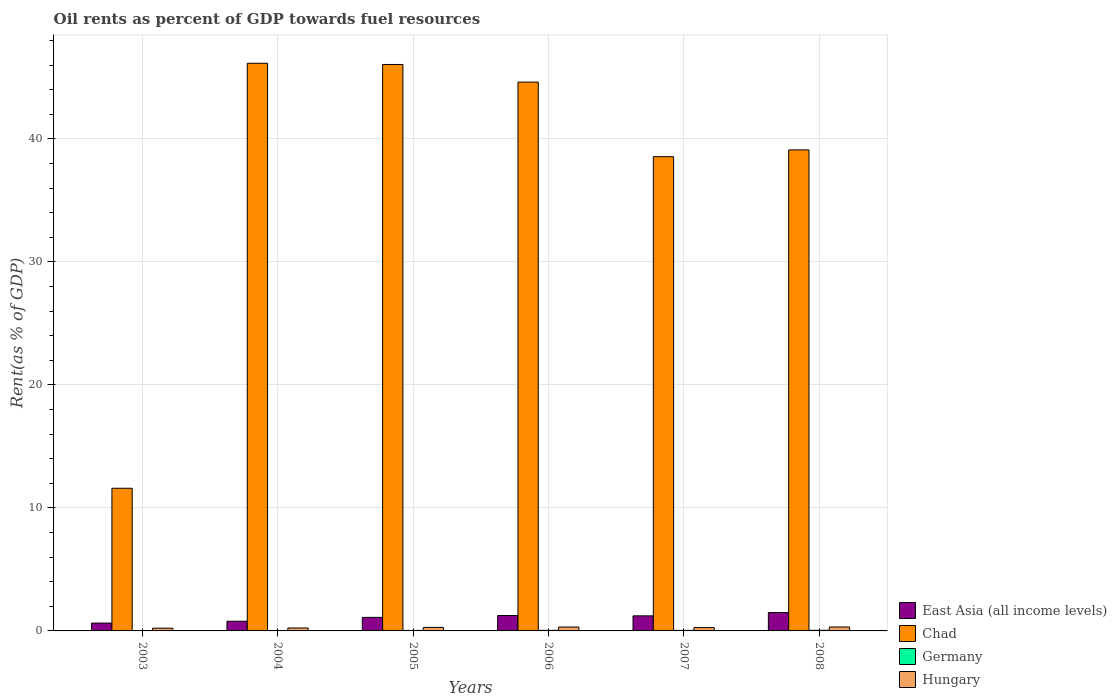How many groups of bars are there?
Offer a very short reply. 6. Are the number of bars per tick equal to the number of legend labels?
Ensure brevity in your answer.  Yes. Are the number of bars on each tick of the X-axis equal?
Ensure brevity in your answer.  Yes. How many bars are there on the 3rd tick from the left?
Keep it short and to the point. 4. In how many cases, is the number of bars for a given year not equal to the number of legend labels?
Offer a terse response. 0. What is the oil rent in Chad in 2004?
Ensure brevity in your answer.  46.15. Across all years, what is the maximum oil rent in Germany?
Give a very brief answer. 0.05. Across all years, what is the minimum oil rent in Germany?
Provide a short and direct response. 0.02. In which year was the oil rent in Hungary maximum?
Provide a short and direct response. 2008. In which year was the oil rent in Chad minimum?
Offer a terse response. 2003. What is the total oil rent in East Asia (all income levels) in the graph?
Your answer should be compact. 6.5. What is the difference between the oil rent in Germany in 2004 and that in 2006?
Ensure brevity in your answer.  -0.02. What is the difference between the oil rent in East Asia (all income levels) in 2007 and the oil rent in Germany in 2005?
Provide a succinct answer. 1.18. What is the average oil rent in Chad per year?
Your response must be concise. 37.68. In the year 2004, what is the difference between the oil rent in Hungary and oil rent in East Asia (all income levels)?
Keep it short and to the point. -0.55. In how many years, is the oil rent in Germany greater than 10 %?
Offer a terse response. 0. What is the ratio of the oil rent in Germany in 2003 to that in 2006?
Ensure brevity in your answer.  0.53. Is the oil rent in Hungary in 2005 less than that in 2006?
Ensure brevity in your answer.  Yes. Is the difference between the oil rent in Hungary in 2006 and 2008 greater than the difference between the oil rent in East Asia (all income levels) in 2006 and 2008?
Provide a succinct answer. Yes. What is the difference between the highest and the second highest oil rent in Hungary?
Make the answer very short. 0. What is the difference between the highest and the lowest oil rent in Hungary?
Your response must be concise. 0.1. Is the sum of the oil rent in Chad in 2003 and 2007 greater than the maximum oil rent in Germany across all years?
Your response must be concise. Yes. What does the 4th bar from the left in 2006 represents?
Ensure brevity in your answer.  Hungary. How many bars are there?
Offer a very short reply. 24. Are all the bars in the graph horizontal?
Keep it short and to the point. No. How many years are there in the graph?
Keep it short and to the point. 6. Are the values on the major ticks of Y-axis written in scientific E-notation?
Ensure brevity in your answer.  No. How are the legend labels stacked?
Keep it short and to the point. Vertical. What is the title of the graph?
Your response must be concise. Oil rents as percent of GDP towards fuel resources. Does "Libya" appear as one of the legend labels in the graph?
Your answer should be compact. No. What is the label or title of the X-axis?
Offer a terse response. Years. What is the label or title of the Y-axis?
Your response must be concise. Rent(as % of GDP). What is the Rent(as % of GDP) in East Asia (all income levels) in 2003?
Keep it short and to the point. 0.64. What is the Rent(as % of GDP) of Chad in 2003?
Your response must be concise. 11.6. What is the Rent(as % of GDP) of Germany in 2003?
Ensure brevity in your answer.  0.02. What is the Rent(as % of GDP) in Hungary in 2003?
Your response must be concise. 0.22. What is the Rent(as % of GDP) in East Asia (all income levels) in 2004?
Ensure brevity in your answer.  0.79. What is the Rent(as % of GDP) in Chad in 2004?
Your answer should be very brief. 46.15. What is the Rent(as % of GDP) in Germany in 2004?
Offer a terse response. 0.03. What is the Rent(as % of GDP) in Hungary in 2004?
Make the answer very short. 0.24. What is the Rent(as % of GDP) in East Asia (all income levels) in 2005?
Offer a terse response. 1.1. What is the Rent(as % of GDP) of Chad in 2005?
Keep it short and to the point. 46.05. What is the Rent(as % of GDP) in Germany in 2005?
Your answer should be compact. 0.04. What is the Rent(as % of GDP) in Hungary in 2005?
Provide a succinct answer. 0.28. What is the Rent(as % of GDP) of East Asia (all income levels) in 2006?
Provide a short and direct response. 1.25. What is the Rent(as % of GDP) in Chad in 2006?
Offer a very short reply. 44.62. What is the Rent(as % of GDP) in Germany in 2006?
Ensure brevity in your answer.  0.05. What is the Rent(as % of GDP) of Hungary in 2006?
Provide a succinct answer. 0.32. What is the Rent(as % of GDP) in East Asia (all income levels) in 2007?
Ensure brevity in your answer.  1.22. What is the Rent(as % of GDP) of Chad in 2007?
Provide a short and direct response. 38.55. What is the Rent(as % of GDP) of Germany in 2007?
Provide a succinct answer. 0.04. What is the Rent(as % of GDP) in Hungary in 2007?
Your answer should be compact. 0.27. What is the Rent(as % of GDP) of East Asia (all income levels) in 2008?
Ensure brevity in your answer.  1.5. What is the Rent(as % of GDP) of Chad in 2008?
Offer a very short reply. 39.11. What is the Rent(as % of GDP) in Germany in 2008?
Give a very brief answer. 0.05. What is the Rent(as % of GDP) of Hungary in 2008?
Offer a terse response. 0.32. Across all years, what is the maximum Rent(as % of GDP) in East Asia (all income levels)?
Your response must be concise. 1.5. Across all years, what is the maximum Rent(as % of GDP) in Chad?
Offer a terse response. 46.15. Across all years, what is the maximum Rent(as % of GDP) of Germany?
Give a very brief answer. 0.05. Across all years, what is the maximum Rent(as % of GDP) of Hungary?
Offer a terse response. 0.32. Across all years, what is the minimum Rent(as % of GDP) in East Asia (all income levels)?
Give a very brief answer. 0.64. Across all years, what is the minimum Rent(as % of GDP) of Chad?
Your answer should be very brief. 11.6. Across all years, what is the minimum Rent(as % of GDP) in Germany?
Offer a very short reply. 0.02. Across all years, what is the minimum Rent(as % of GDP) in Hungary?
Your answer should be very brief. 0.22. What is the total Rent(as % of GDP) in East Asia (all income levels) in the graph?
Offer a terse response. 6.5. What is the total Rent(as % of GDP) of Chad in the graph?
Your answer should be compact. 226.07. What is the total Rent(as % of GDP) in Germany in the graph?
Offer a very short reply. 0.23. What is the total Rent(as % of GDP) in Hungary in the graph?
Your answer should be very brief. 1.65. What is the difference between the Rent(as % of GDP) in East Asia (all income levels) in 2003 and that in 2004?
Provide a short and direct response. -0.15. What is the difference between the Rent(as % of GDP) in Chad in 2003 and that in 2004?
Your answer should be compact. -34.55. What is the difference between the Rent(as % of GDP) of Germany in 2003 and that in 2004?
Provide a succinct answer. -0. What is the difference between the Rent(as % of GDP) in Hungary in 2003 and that in 2004?
Your answer should be compact. -0.02. What is the difference between the Rent(as % of GDP) in East Asia (all income levels) in 2003 and that in 2005?
Offer a very short reply. -0.46. What is the difference between the Rent(as % of GDP) of Chad in 2003 and that in 2005?
Your response must be concise. -34.45. What is the difference between the Rent(as % of GDP) in Germany in 2003 and that in 2005?
Provide a short and direct response. -0.02. What is the difference between the Rent(as % of GDP) of Hungary in 2003 and that in 2005?
Ensure brevity in your answer.  -0.06. What is the difference between the Rent(as % of GDP) in East Asia (all income levels) in 2003 and that in 2006?
Keep it short and to the point. -0.61. What is the difference between the Rent(as % of GDP) in Chad in 2003 and that in 2006?
Your response must be concise. -33.02. What is the difference between the Rent(as % of GDP) of Germany in 2003 and that in 2006?
Ensure brevity in your answer.  -0.02. What is the difference between the Rent(as % of GDP) of Hungary in 2003 and that in 2006?
Make the answer very short. -0.09. What is the difference between the Rent(as % of GDP) in East Asia (all income levels) in 2003 and that in 2007?
Your response must be concise. -0.59. What is the difference between the Rent(as % of GDP) in Chad in 2003 and that in 2007?
Make the answer very short. -26.96. What is the difference between the Rent(as % of GDP) of Germany in 2003 and that in 2007?
Keep it short and to the point. -0.02. What is the difference between the Rent(as % of GDP) in Hungary in 2003 and that in 2007?
Your answer should be very brief. -0.05. What is the difference between the Rent(as % of GDP) of East Asia (all income levels) in 2003 and that in 2008?
Give a very brief answer. -0.86. What is the difference between the Rent(as % of GDP) in Chad in 2003 and that in 2008?
Your answer should be very brief. -27.51. What is the difference between the Rent(as % of GDP) of Germany in 2003 and that in 2008?
Your response must be concise. -0.03. What is the difference between the Rent(as % of GDP) of Hungary in 2003 and that in 2008?
Make the answer very short. -0.1. What is the difference between the Rent(as % of GDP) of East Asia (all income levels) in 2004 and that in 2005?
Your answer should be compact. -0.31. What is the difference between the Rent(as % of GDP) in Chad in 2004 and that in 2005?
Offer a terse response. 0.1. What is the difference between the Rent(as % of GDP) of Germany in 2004 and that in 2005?
Keep it short and to the point. -0.01. What is the difference between the Rent(as % of GDP) of Hungary in 2004 and that in 2005?
Provide a short and direct response. -0.05. What is the difference between the Rent(as % of GDP) in East Asia (all income levels) in 2004 and that in 2006?
Keep it short and to the point. -0.46. What is the difference between the Rent(as % of GDP) of Chad in 2004 and that in 2006?
Ensure brevity in your answer.  1.53. What is the difference between the Rent(as % of GDP) in Germany in 2004 and that in 2006?
Give a very brief answer. -0.02. What is the difference between the Rent(as % of GDP) of Hungary in 2004 and that in 2006?
Ensure brevity in your answer.  -0.08. What is the difference between the Rent(as % of GDP) of East Asia (all income levels) in 2004 and that in 2007?
Offer a terse response. -0.44. What is the difference between the Rent(as % of GDP) in Chad in 2004 and that in 2007?
Give a very brief answer. 7.6. What is the difference between the Rent(as % of GDP) of Germany in 2004 and that in 2007?
Your answer should be compact. -0.02. What is the difference between the Rent(as % of GDP) in Hungary in 2004 and that in 2007?
Provide a short and direct response. -0.03. What is the difference between the Rent(as % of GDP) in East Asia (all income levels) in 2004 and that in 2008?
Offer a terse response. -0.71. What is the difference between the Rent(as % of GDP) in Chad in 2004 and that in 2008?
Offer a terse response. 7.04. What is the difference between the Rent(as % of GDP) in Germany in 2004 and that in 2008?
Keep it short and to the point. -0.02. What is the difference between the Rent(as % of GDP) of Hungary in 2004 and that in 2008?
Offer a very short reply. -0.08. What is the difference between the Rent(as % of GDP) in East Asia (all income levels) in 2005 and that in 2006?
Offer a terse response. -0.15. What is the difference between the Rent(as % of GDP) in Chad in 2005 and that in 2006?
Your answer should be very brief. 1.43. What is the difference between the Rent(as % of GDP) of Germany in 2005 and that in 2006?
Give a very brief answer. -0.01. What is the difference between the Rent(as % of GDP) of Hungary in 2005 and that in 2006?
Offer a very short reply. -0.03. What is the difference between the Rent(as % of GDP) in East Asia (all income levels) in 2005 and that in 2007?
Provide a succinct answer. -0.12. What is the difference between the Rent(as % of GDP) in Chad in 2005 and that in 2007?
Make the answer very short. 7.5. What is the difference between the Rent(as % of GDP) in Germany in 2005 and that in 2007?
Your answer should be compact. -0. What is the difference between the Rent(as % of GDP) in Hungary in 2005 and that in 2007?
Your answer should be compact. 0.01. What is the difference between the Rent(as % of GDP) of East Asia (all income levels) in 2005 and that in 2008?
Give a very brief answer. -0.39. What is the difference between the Rent(as % of GDP) of Chad in 2005 and that in 2008?
Provide a succinct answer. 6.94. What is the difference between the Rent(as % of GDP) of Germany in 2005 and that in 2008?
Your answer should be very brief. -0.01. What is the difference between the Rent(as % of GDP) in Hungary in 2005 and that in 2008?
Offer a very short reply. -0.04. What is the difference between the Rent(as % of GDP) of East Asia (all income levels) in 2006 and that in 2007?
Your answer should be compact. 0.03. What is the difference between the Rent(as % of GDP) in Chad in 2006 and that in 2007?
Your answer should be very brief. 6.06. What is the difference between the Rent(as % of GDP) in Germany in 2006 and that in 2007?
Offer a terse response. 0. What is the difference between the Rent(as % of GDP) in Hungary in 2006 and that in 2007?
Your answer should be compact. 0.04. What is the difference between the Rent(as % of GDP) in East Asia (all income levels) in 2006 and that in 2008?
Provide a succinct answer. -0.24. What is the difference between the Rent(as % of GDP) in Chad in 2006 and that in 2008?
Ensure brevity in your answer.  5.51. What is the difference between the Rent(as % of GDP) of Germany in 2006 and that in 2008?
Your response must be concise. -0. What is the difference between the Rent(as % of GDP) in Hungary in 2006 and that in 2008?
Keep it short and to the point. -0. What is the difference between the Rent(as % of GDP) in East Asia (all income levels) in 2007 and that in 2008?
Offer a very short reply. -0.27. What is the difference between the Rent(as % of GDP) in Chad in 2007 and that in 2008?
Ensure brevity in your answer.  -0.55. What is the difference between the Rent(as % of GDP) of Germany in 2007 and that in 2008?
Your answer should be compact. -0.01. What is the difference between the Rent(as % of GDP) in Hungary in 2007 and that in 2008?
Provide a succinct answer. -0.05. What is the difference between the Rent(as % of GDP) of East Asia (all income levels) in 2003 and the Rent(as % of GDP) of Chad in 2004?
Your answer should be very brief. -45.51. What is the difference between the Rent(as % of GDP) of East Asia (all income levels) in 2003 and the Rent(as % of GDP) of Germany in 2004?
Give a very brief answer. 0.61. What is the difference between the Rent(as % of GDP) in East Asia (all income levels) in 2003 and the Rent(as % of GDP) in Hungary in 2004?
Provide a short and direct response. 0.4. What is the difference between the Rent(as % of GDP) in Chad in 2003 and the Rent(as % of GDP) in Germany in 2004?
Keep it short and to the point. 11.57. What is the difference between the Rent(as % of GDP) of Chad in 2003 and the Rent(as % of GDP) of Hungary in 2004?
Your response must be concise. 11.36. What is the difference between the Rent(as % of GDP) in Germany in 2003 and the Rent(as % of GDP) in Hungary in 2004?
Offer a very short reply. -0.21. What is the difference between the Rent(as % of GDP) of East Asia (all income levels) in 2003 and the Rent(as % of GDP) of Chad in 2005?
Your response must be concise. -45.41. What is the difference between the Rent(as % of GDP) in East Asia (all income levels) in 2003 and the Rent(as % of GDP) in Germany in 2005?
Make the answer very short. 0.6. What is the difference between the Rent(as % of GDP) in East Asia (all income levels) in 2003 and the Rent(as % of GDP) in Hungary in 2005?
Give a very brief answer. 0.35. What is the difference between the Rent(as % of GDP) in Chad in 2003 and the Rent(as % of GDP) in Germany in 2005?
Offer a terse response. 11.56. What is the difference between the Rent(as % of GDP) in Chad in 2003 and the Rent(as % of GDP) in Hungary in 2005?
Offer a terse response. 11.31. What is the difference between the Rent(as % of GDP) in Germany in 2003 and the Rent(as % of GDP) in Hungary in 2005?
Offer a terse response. -0.26. What is the difference between the Rent(as % of GDP) of East Asia (all income levels) in 2003 and the Rent(as % of GDP) of Chad in 2006?
Keep it short and to the point. -43.98. What is the difference between the Rent(as % of GDP) of East Asia (all income levels) in 2003 and the Rent(as % of GDP) of Germany in 2006?
Provide a short and direct response. 0.59. What is the difference between the Rent(as % of GDP) in East Asia (all income levels) in 2003 and the Rent(as % of GDP) in Hungary in 2006?
Ensure brevity in your answer.  0.32. What is the difference between the Rent(as % of GDP) in Chad in 2003 and the Rent(as % of GDP) in Germany in 2006?
Ensure brevity in your answer.  11.55. What is the difference between the Rent(as % of GDP) in Chad in 2003 and the Rent(as % of GDP) in Hungary in 2006?
Provide a short and direct response. 11.28. What is the difference between the Rent(as % of GDP) of Germany in 2003 and the Rent(as % of GDP) of Hungary in 2006?
Keep it short and to the point. -0.29. What is the difference between the Rent(as % of GDP) of East Asia (all income levels) in 2003 and the Rent(as % of GDP) of Chad in 2007?
Provide a succinct answer. -37.92. What is the difference between the Rent(as % of GDP) of East Asia (all income levels) in 2003 and the Rent(as % of GDP) of Germany in 2007?
Provide a short and direct response. 0.59. What is the difference between the Rent(as % of GDP) of East Asia (all income levels) in 2003 and the Rent(as % of GDP) of Hungary in 2007?
Keep it short and to the point. 0.37. What is the difference between the Rent(as % of GDP) in Chad in 2003 and the Rent(as % of GDP) in Germany in 2007?
Offer a terse response. 11.55. What is the difference between the Rent(as % of GDP) of Chad in 2003 and the Rent(as % of GDP) of Hungary in 2007?
Ensure brevity in your answer.  11.33. What is the difference between the Rent(as % of GDP) of Germany in 2003 and the Rent(as % of GDP) of Hungary in 2007?
Make the answer very short. -0.25. What is the difference between the Rent(as % of GDP) in East Asia (all income levels) in 2003 and the Rent(as % of GDP) in Chad in 2008?
Ensure brevity in your answer.  -38.47. What is the difference between the Rent(as % of GDP) of East Asia (all income levels) in 2003 and the Rent(as % of GDP) of Germany in 2008?
Keep it short and to the point. 0.59. What is the difference between the Rent(as % of GDP) of East Asia (all income levels) in 2003 and the Rent(as % of GDP) of Hungary in 2008?
Offer a terse response. 0.32. What is the difference between the Rent(as % of GDP) of Chad in 2003 and the Rent(as % of GDP) of Germany in 2008?
Give a very brief answer. 11.55. What is the difference between the Rent(as % of GDP) in Chad in 2003 and the Rent(as % of GDP) in Hungary in 2008?
Provide a short and direct response. 11.28. What is the difference between the Rent(as % of GDP) of Germany in 2003 and the Rent(as % of GDP) of Hungary in 2008?
Give a very brief answer. -0.3. What is the difference between the Rent(as % of GDP) of East Asia (all income levels) in 2004 and the Rent(as % of GDP) of Chad in 2005?
Ensure brevity in your answer.  -45.26. What is the difference between the Rent(as % of GDP) in East Asia (all income levels) in 2004 and the Rent(as % of GDP) in Germany in 2005?
Provide a succinct answer. 0.75. What is the difference between the Rent(as % of GDP) in East Asia (all income levels) in 2004 and the Rent(as % of GDP) in Hungary in 2005?
Provide a short and direct response. 0.5. What is the difference between the Rent(as % of GDP) of Chad in 2004 and the Rent(as % of GDP) of Germany in 2005?
Ensure brevity in your answer.  46.11. What is the difference between the Rent(as % of GDP) of Chad in 2004 and the Rent(as % of GDP) of Hungary in 2005?
Your answer should be very brief. 45.86. What is the difference between the Rent(as % of GDP) in Germany in 2004 and the Rent(as % of GDP) in Hungary in 2005?
Offer a very short reply. -0.26. What is the difference between the Rent(as % of GDP) in East Asia (all income levels) in 2004 and the Rent(as % of GDP) in Chad in 2006?
Offer a very short reply. -43.83. What is the difference between the Rent(as % of GDP) of East Asia (all income levels) in 2004 and the Rent(as % of GDP) of Germany in 2006?
Your answer should be compact. 0.74. What is the difference between the Rent(as % of GDP) in East Asia (all income levels) in 2004 and the Rent(as % of GDP) in Hungary in 2006?
Your answer should be compact. 0.47. What is the difference between the Rent(as % of GDP) in Chad in 2004 and the Rent(as % of GDP) in Germany in 2006?
Give a very brief answer. 46.1. What is the difference between the Rent(as % of GDP) of Chad in 2004 and the Rent(as % of GDP) of Hungary in 2006?
Your response must be concise. 45.83. What is the difference between the Rent(as % of GDP) in Germany in 2004 and the Rent(as % of GDP) in Hungary in 2006?
Give a very brief answer. -0.29. What is the difference between the Rent(as % of GDP) in East Asia (all income levels) in 2004 and the Rent(as % of GDP) in Chad in 2007?
Your response must be concise. -37.77. What is the difference between the Rent(as % of GDP) of East Asia (all income levels) in 2004 and the Rent(as % of GDP) of Germany in 2007?
Give a very brief answer. 0.74. What is the difference between the Rent(as % of GDP) of East Asia (all income levels) in 2004 and the Rent(as % of GDP) of Hungary in 2007?
Your answer should be very brief. 0.52. What is the difference between the Rent(as % of GDP) of Chad in 2004 and the Rent(as % of GDP) of Germany in 2007?
Your answer should be compact. 46.11. What is the difference between the Rent(as % of GDP) in Chad in 2004 and the Rent(as % of GDP) in Hungary in 2007?
Your response must be concise. 45.88. What is the difference between the Rent(as % of GDP) of Germany in 2004 and the Rent(as % of GDP) of Hungary in 2007?
Keep it short and to the point. -0.24. What is the difference between the Rent(as % of GDP) of East Asia (all income levels) in 2004 and the Rent(as % of GDP) of Chad in 2008?
Provide a succinct answer. -38.32. What is the difference between the Rent(as % of GDP) in East Asia (all income levels) in 2004 and the Rent(as % of GDP) in Germany in 2008?
Offer a terse response. 0.74. What is the difference between the Rent(as % of GDP) in East Asia (all income levels) in 2004 and the Rent(as % of GDP) in Hungary in 2008?
Give a very brief answer. 0.47. What is the difference between the Rent(as % of GDP) of Chad in 2004 and the Rent(as % of GDP) of Germany in 2008?
Offer a very short reply. 46.1. What is the difference between the Rent(as % of GDP) of Chad in 2004 and the Rent(as % of GDP) of Hungary in 2008?
Offer a terse response. 45.83. What is the difference between the Rent(as % of GDP) in Germany in 2004 and the Rent(as % of GDP) in Hungary in 2008?
Your response must be concise. -0.29. What is the difference between the Rent(as % of GDP) of East Asia (all income levels) in 2005 and the Rent(as % of GDP) of Chad in 2006?
Offer a terse response. -43.51. What is the difference between the Rent(as % of GDP) of East Asia (all income levels) in 2005 and the Rent(as % of GDP) of Germany in 2006?
Provide a short and direct response. 1.06. What is the difference between the Rent(as % of GDP) in East Asia (all income levels) in 2005 and the Rent(as % of GDP) in Hungary in 2006?
Give a very brief answer. 0.79. What is the difference between the Rent(as % of GDP) of Chad in 2005 and the Rent(as % of GDP) of Germany in 2006?
Ensure brevity in your answer.  46. What is the difference between the Rent(as % of GDP) in Chad in 2005 and the Rent(as % of GDP) in Hungary in 2006?
Provide a short and direct response. 45.73. What is the difference between the Rent(as % of GDP) in Germany in 2005 and the Rent(as % of GDP) in Hungary in 2006?
Offer a terse response. -0.28. What is the difference between the Rent(as % of GDP) of East Asia (all income levels) in 2005 and the Rent(as % of GDP) of Chad in 2007?
Your answer should be compact. -37.45. What is the difference between the Rent(as % of GDP) in East Asia (all income levels) in 2005 and the Rent(as % of GDP) in Germany in 2007?
Provide a short and direct response. 1.06. What is the difference between the Rent(as % of GDP) of East Asia (all income levels) in 2005 and the Rent(as % of GDP) of Hungary in 2007?
Your response must be concise. 0.83. What is the difference between the Rent(as % of GDP) in Chad in 2005 and the Rent(as % of GDP) in Germany in 2007?
Give a very brief answer. 46.01. What is the difference between the Rent(as % of GDP) of Chad in 2005 and the Rent(as % of GDP) of Hungary in 2007?
Ensure brevity in your answer.  45.78. What is the difference between the Rent(as % of GDP) in Germany in 2005 and the Rent(as % of GDP) in Hungary in 2007?
Your answer should be compact. -0.23. What is the difference between the Rent(as % of GDP) of East Asia (all income levels) in 2005 and the Rent(as % of GDP) of Chad in 2008?
Your answer should be compact. -38. What is the difference between the Rent(as % of GDP) of East Asia (all income levels) in 2005 and the Rent(as % of GDP) of Germany in 2008?
Make the answer very short. 1.05. What is the difference between the Rent(as % of GDP) of East Asia (all income levels) in 2005 and the Rent(as % of GDP) of Hungary in 2008?
Keep it short and to the point. 0.78. What is the difference between the Rent(as % of GDP) of Chad in 2005 and the Rent(as % of GDP) of Germany in 2008?
Your response must be concise. 46. What is the difference between the Rent(as % of GDP) in Chad in 2005 and the Rent(as % of GDP) in Hungary in 2008?
Your answer should be very brief. 45.73. What is the difference between the Rent(as % of GDP) of Germany in 2005 and the Rent(as % of GDP) of Hungary in 2008?
Keep it short and to the point. -0.28. What is the difference between the Rent(as % of GDP) of East Asia (all income levels) in 2006 and the Rent(as % of GDP) of Chad in 2007?
Your response must be concise. -37.3. What is the difference between the Rent(as % of GDP) of East Asia (all income levels) in 2006 and the Rent(as % of GDP) of Germany in 2007?
Give a very brief answer. 1.21. What is the difference between the Rent(as % of GDP) of East Asia (all income levels) in 2006 and the Rent(as % of GDP) of Hungary in 2007?
Your answer should be very brief. 0.98. What is the difference between the Rent(as % of GDP) in Chad in 2006 and the Rent(as % of GDP) in Germany in 2007?
Keep it short and to the point. 44.57. What is the difference between the Rent(as % of GDP) in Chad in 2006 and the Rent(as % of GDP) in Hungary in 2007?
Your response must be concise. 44.35. What is the difference between the Rent(as % of GDP) of Germany in 2006 and the Rent(as % of GDP) of Hungary in 2007?
Provide a succinct answer. -0.23. What is the difference between the Rent(as % of GDP) in East Asia (all income levels) in 2006 and the Rent(as % of GDP) in Chad in 2008?
Your response must be concise. -37.85. What is the difference between the Rent(as % of GDP) in East Asia (all income levels) in 2006 and the Rent(as % of GDP) in Germany in 2008?
Offer a very short reply. 1.2. What is the difference between the Rent(as % of GDP) in East Asia (all income levels) in 2006 and the Rent(as % of GDP) in Hungary in 2008?
Keep it short and to the point. 0.93. What is the difference between the Rent(as % of GDP) of Chad in 2006 and the Rent(as % of GDP) of Germany in 2008?
Keep it short and to the point. 44.57. What is the difference between the Rent(as % of GDP) in Chad in 2006 and the Rent(as % of GDP) in Hungary in 2008?
Make the answer very short. 44.3. What is the difference between the Rent(as % of GDP) of Germany in 2006 and the Rent(as % of GDP) of Hungary in 2008?
Offer a very short reply. -0.27. What is the difference between the Rent(as % of GDP) of East Asia (all income levels) in 2007 and the Rent(as % of GDP) of Chad in 2008?
Offer a terse response. -37.88. What is the difference between the Rent(as % of GDP) in East Asia (all income levels) in 2007 and the Rent(as % of GDP) in Germany in 2008?
Ensure brevity in your answer.  1.18. What is the difference between the Rent(as % of GDP) of East Asia (all income levels) in 2007 and the Rent(as % of GDP) of Hungary in 2008?
Keep it short and to the point. 0.9. What is the difference between the Rent(as % of GDP) of Chad in 2007 and the Rent(as % of GDP) of Germany in 2008?
Your answer should be compact. 38.5. What is the difference between the Rent(as % of GDP) in Chad in 2007 and the Rent(as % of GDP) in Hungary in 2008?
Your answer should be very brief. 38.23. What is the difference between the Rent(as % of GDP) in Germany in 2007 and the Rent(as % of GDP) in Hungary in 2008?
Make the answer very short. -0.28. What is the average Rent(as % of GDP) of East Asia (all income levels) per year?
Ensure brevity in your answer.  1.08. What is the average Rent(as % of GDP) of Chad per year?
Offer a terse response. 37.68. What is the average Rent(as % of GDP) in Germany per year?
Offer a very short reply. 0.04. What is the average Rent(as % of GDP) in Hungary per year?
Your answer should be compact. 0.28. In the year 2003, what is the difference between the Rent(as % of GDP) in East Asia (all income levels) and Rent(as % of GDP) in Chad?
Give a very brief answer. -10.96. In the year 2003, what is the difference between the Rent(as % of GDP) in East Asia (all income levels) and Rent(as % of GDP) in Germany?
Offer a very short reply. 0.61. In the year 2003, what is the difference between the Rent(as % of GDP) of East Asia (all income levels) and Rent(as % of GDP) of Hungary?
Your answer should be very brief. 0.42. In the year 2003, what is the difference between the Rent(as % of GDP) in Chad and Rent(as % of GDP) in Germany?
Make the answer very short. 11.57. In the year 2003, what is the difference between the Rent(as % of GDP) of Chad and Rent(as % of GDP) of Hungary?
Your answer should be compact. 11.38. In the year 2003, what is the difference between the Rent(as % of GDP) in Germany and Rent(as % of GDP) in Hungary?
Give a very brief answer. -0.2. In the year 2004, what is the difference between the Rent(as % of GDP) of East Asia (all income levels) and Rent(as % of GDP) of Chad?
Give a very brief answer. -45.36. In the year 2004, what is the difference between the Rent(as % of GDP) in East Asia (all income levels) and Rent(as % of GDP) in Germany?
Offer a very short reply. 0.76. In the year 2004, what is the difference between the Rent(as % of GDP) of East Asia (all income levels) and Rent(as % of GDP) of Hungary?
Give a very brief answer. 0.55. In the year 2004, what is the difference between the Rent(as % of GDP) in Chad and Rent(as % of GDP) in Germany?
Give a very brief answer. 46.12. In the year 2004, what is the difference between the Rent(as % of GDP) in Chad and Rent(as % of GDP) in Hungary?
Your response must be concise. 45.91. In the year 2004, what is the difference between the Rent(as % of GDP) in Germany and Rent(as % of GDP) in Hungary?
Ensure brevity in your answer.  -0.21. In the year 2005, what is the difference between the Rent(as % of GDP) in East Asia (all income levels) and Rent(as % of GDP) in Chad?
Offer a very short reply. -44.95. In the year 2005, what is the difference between the Rent(as % of GDP) of East Asia (all income levels) and Rent(as % of GDP) of Germany?
Make the answer very short. 1.06. In the year 2005, what is the difference between the Rent(as % of GDP) in East Asia (all income levels) and Rent(as % of GDP) in Hungary?
Offer a very short reply. 0.82. In the year 2005, what is the difference between the Rent(as % of GDP) in Chad and Rent(as % of GDP) in Germany?
Offer a very short reply. 46.01. In the year 2005, what is the difference between the Rent(as % of GDP) in Chad and Rent(as % of GDP) in Hungary?
Provide a short and direct response. 45.77. In the year 2005, what is the difference between the Rent(as % of GDP) in Germany and Rent(as % of GDP) in Hungary?
Your answer should be very brief. -0.24. In the year 2006, what is the difference between the Rent(as % of GDP) in East Asia (all income levels) and Rent(as % of GDP) in Chad?
Your response must be concise. -43.37. In the year 2006, what is the difference between the Rent(as % of GDP) in East Asia (all income levels) and Rent(as % of GDP) in Germany?
Ensure brevity in your answer.  1.21. In the year 2006, what is the difference between the Rent(as % of GDP) in East Asia (all income levels) and Rent(as % of GDP) in Hungary?
Keep it short and to the point. 0.94. In the year 2006, what is the difference between the Rent(as % of GDP) of Chad and Rent(as % of GDP) of Germany?
Offer a terse response. 44.57. In the year 2006, what is the difference between the Rent(as % of GDP) in Chad and Rent(as % of GDP) in Hungary?
Offer a terse response. 44.3. In the year 2006, what is the difference between the Rent(as % of GDP) of Germany and Rent(as % of GDP) of Hungary?
Provide a short and direct response. -0.27. In the year 2007, what is the difference between the Rent(as % of GDP) of East Asia (all income levels) and Rent(as % of GDP) of Chad?
Make the answer very short. -37.33. In the year 2007, what is the difference between the Rent(as % of GDP) of East Asia (all income levels) and Rent(as % of GDP) of Germany?
Offer a very short reply. 1.18. In the year 2007, what is the difference between the Rent(as % of GDP) of East Asia (all income levels) and Rent(as % of GDP) of Hungary?
Provide a succinct answer. 0.95. In the year 2007, what is the difference between the Rent(as % of GDP) in Chad and Rent(as % of GDP) in Germany?
Give a very brief answer. 38.51. In the year 2007, what is the difference between the Rent(as % of GDP) of Chad and Rent(as % of GDP) of Hungary?
Your response must be concise. 38.28. In the year 2007, what is the difference between the Rent(as % of GDP) in Germany and Rent(as % of GDP) in Hungary?
Make the answer very short. -0.23. In the year 2008, what is the difference between the Rent(as % of GDP) of East Asia (all income levels) and Rent(as % of GDP) of Chad?
Make the answer very short. -37.61. In the year 2008, what is the difference between the Rent(as % of GDP) of East Asia (all income levels) and Rent(as % of GDP) of Germany?
Keep it short and to the point. 1.45. In the year 2008, what is the difference between the Rent(as % of GDP) of East Asia (all income levels) and Rent(as % of GDP) of Hungary?
Give a very brief answer. 1.18. In the year 2008, what is the difference between the Rent(as % of GDP) in Chad and Rent(as % of GDP) in Germany?
Offer a very short reply. 39.06. In the year 2008, what is the difference between the Rent(as % of GDP) in Chad and Rent(as % of GDP) in Hungary?
Offer a terse response. 38.79. In the year 2008, what is the difference between the Rent(as % of GDP) in Germany and Rent(as % of GDP) in Hungary?
Provide a succinct answer. -0.27. What is the ratio of the Rent(as % of GDP) in East Asia (all income levels) in 2003 to that in 2004?
Provide a short and direct response. 0.81. What is the ratio of the Rent(as % of GDP) in Chad in 2003 to that in 2004?
Offer a terse response. 0.25. What is the ratio of the Rent(as % of GDP) of Germany in 2003 to that in 2004?
Offer a very short reply. 0.87. What is the ratio of the Rent(as % of GDP) in Hungary in 2003 to that in 2004?
Offer a very short reply. 0.93. What is the ratio of the Rent(as % of GDP) of East Asia (all income levels) in 2003 to that in 2005?
Offer a very short reply. 0.58. What is the ratio of the Rent(as % of GDP) of Chad in 2003 to that in 2005?
Offer a very short reply. 0.25. What is the ratio of the Rent(as % of GDP) of Germany in 2003 to that in 2005?
Provide a short and direct response. 0.6. What is the ratio of the Rent(as % of GDP) in Hungary in 2003 to that in 2005?
Offer a very short reply. 0.78. What is the ratio of the Rent(as % of GDP) in East Asia (all income levels) in 2003 to that in 2006?
Keep it short and to the point. 0.51. What is the ratio of the Rent(as % of GDP) of Chad in 2003 to that in 2006?
Your answer should be compact. 0.26. What is the ratio of the Rent(as % of GDP) in Germany in 2003 to that in 2006?
Your answer should be compact. 0.53. What is the ratio of the Rent(as % of GDP) of Hungary in 2003 to that in 2006?
Provide a short and direct response. 0.71. What is the ratio of the Rent(as % of GDP) in East Asia (all income levels) in 2003 to that in 2007?
Your response must be concise. 0.52. What is the ratio of the Rent(as % of GDP) in Chad in 2003 to that in 2007?
Keep it short and to the point. 0.3. What is the ratio of the Rent(as % of GDP) in Germany in 2003 to that in 2007?
Offer a terse response. 0.56. What is the ratio of the Rent(as % of GDP) in Hungary in 2003 to that in 2007?
Offer a terse response. 0.82. What is the ratio of the Rent(as % of GDP) in East Asia (all income levels) in 2003 to that in 2008?
Ensure brevity in your answer.  0.43. What is the ratio of the Rent(as % of GDP) in Chad in 2003 to that in 2008?
Offer a terse response. 0.3. What is the ratio of the Rent(as % of GDP) in Germany in 2003 to that in 2008?
Make the answer very short. 0.49. What is the ratio of the Rent(as % of GDP) of Hungary in 2003 to that in 2008?
Your answer should be compact. 0.7. What is the ratio of the Rent(as % of GDP) in East Asia (all income levels) in 2004 to that in 2005?
Make the answer very short. 0.71. What is the ratio of the Rent(as % of GDP) in Chad in 2004 to that in 2005?
Provide a short and direct response. 1. What is the ratio of the Rent(as % of GDP) of Germany in 2004 to that in 2005?
Give a very brief answer. 0.69. What is the ratio of the Rent(as % of GDP) in Hungary in 2004 to that in 2005?
Provide a short and direct response. 0.84. What is the ratio of the Rent(as % of GDP) in East Asia (all income levels) in 2004 to that in 2006?
Your answer should be compact. 0.63. What is the ratio of the Rent(as % of GDP) in Chad in 2004 to that in 2006?
Offer a very short reply. 1.03. What is the ratio of the Rent(as % of GDP) of Germany in 2004 to that in 2006?
Keep it short and to the point. 0.61. What is the ratio of the Rent(as % of GDP) of Hungary in 2004 to that in 2006?
Provide a short and direct response. 0.76. What is the ratio of the Rent(as % of GDP) in East Asia (all income levels) in 2004 to that in 2007?
Give a very brief answer. 0.64. What is the ratio of the Rent(as % of GDP) in Chad in 2004 to that in 2007?
Your answer should be very brief. 1.2. What is the ratio of the Rent(as % of GDP) of Germany in 2004 to that in 2007?
Give a very brief answer. 0.64. What is the ratio of the Rent(as % of GDP) in Hungary in 2004 to that in 2007?
Your answer should be very brief. 0.88. What is the ratio of the Rent(as % of GDP) of East Asia (all income levels) in 2004 to that in 2008?
Your answer should be very brief. 0.53. What is the ratio of the Rent(as % of GDP) of Chad in 2004 to that in 2008?
Offer a very short reply. 1.18. What is the ratio of the Rent(as % of GDP) of Germany in 2004 to that in 2008?
Your answer should be very brief. 0.56. What is the ratio of the Rent(as % of GDP) of Hungary in 2004 to that in 2008?
Make the answer very short. 0.75. What is the ratio of the Rent(as % of GDP) in East Asia (all income levels) in 2005 to that in 2006?
Your answer should be very brief. 0.88. What is the ratio of the Rent(as % of GDP) of Chad in 2005 to that in 2006?
Provide a short and direct response. 1.03. What is the ratio of the Rent(as % of GDP) in Germany in 2005 to that in 2006?
Make the answer very short. 0.89. What is the ratio of the Rent(as % of GDP) of Hungary in 2005 to that in 2006?
Make the answer very short. 0.9. What is the ratio of the Rent(as % of GDP) in Chad in 2005 to that in 2007?
Your answer should be very brief. 1.19. What is the ratio of the Rent(as % of GDP) in Germany in 2005 to that in 2007?
Provide a short and direct response. 0.93. What is the ratio of the Rent(as % of GDP) in Hungary in 2005 to that in 2007?
Provide a short and direct response. 1.05. What is the ratio of the Rent(as % of GDP) in East Asia (all income levels) in 2005 to that in 2008?
Ensure brevity in your answer.  0.74. What is the ratio of the Rent(as % of GDP) of Chad in 2005 to that in 2008?
Make the answer very short. 1.18. What is the ratio of the Rent(as % of GDP) in Germany in 2005 to that in 2008?
Provide a short and direct response. 0.82. What is the ratio of the Rent(as % of GDP) of Hungary in 2005 to that in 2008?
Ensure brevity in your answer.  0.89. What is the ratio of the Rent(as % of GDP) of East Asia (all income levels) in 2006 to that in 2007?
Provide a short and direct response. 1.02. What is the ratio of the Rent(as % of GDP) of Chad in 2006 to that in 2007?
Your response must be concise. 1.16. What is the ratio of the Rent(as % of GDP) in Germany in 2006 to that in 2007?
Your answer should be very brief. 1.05. What is the ratio of the Rent(as % of GDP) in Hungary in 2006 to that in 2007?
Provide a succinct answer. 1.16. What is the ratio of the Rent(as % of GDP) in East Asia (all income levels) in 2006 to that in 2008?
Your response must be concise. 0.84. What is the ratio of the Rent(as % of GDP) of Chad in 2006 to that in 2008?
Offer a terse response. 1.14. What is the ratio of the Rent(as % of GDP) in Germany in 2006 to that in 2008?
Your answer should be compact. 0.92. What is the ratio of the Rent(as % of GDP) in East Asia (all income levels) in 2007 to that in 2008?
Your answer should be very brief. 0.82. What is the ratio of the Rent(as % of GDP) in Chad in 2007 to that in 2008?
Offer a very short reply. 0.99. What is the ratio of the Rent(as % of GDP) in Germany in 2007 to that in 2008?
Provide a succinct answer. 0.88. What is the ratio of the Rent(as % of GDP) of Hungary in 2007 to that in 2008?
Offer a very short reply. 0.85. What is the difference between the highest and the second highest Rent(as % of GDP) of East Asia (all income levels)?
Make the answer very short. 0.24. What is the difference between the highest and the second highest Rent(as % of GDP) in Chad?
Ensure brevity in your answer.  0.1. What is the difference between the highest and the second highest Rent(as % of GDP) in Germany?
Offer a terse response. 0. What is the difference between the highest and the second highest Rent(as % of GDP) of Hungary?
Your answer should be compact. 0. What is the difference between the highest and the lowest Rent(as % of GDP) in East Asia (all income levels)?
Your answer should be compact. 0.86. What is the difference between the highest and the lowest Rent(as % of GDP) of Chad?
Your answer should be compact. 34.55. What is the difference between the highest and the lowest Rent(as % of GDP) in Germany?
Offer a terse response. 0.03. What is the difference between the highest and the lowest Rent(as % of GDP) of Hungary?
Make the answer very short. 0.1. 